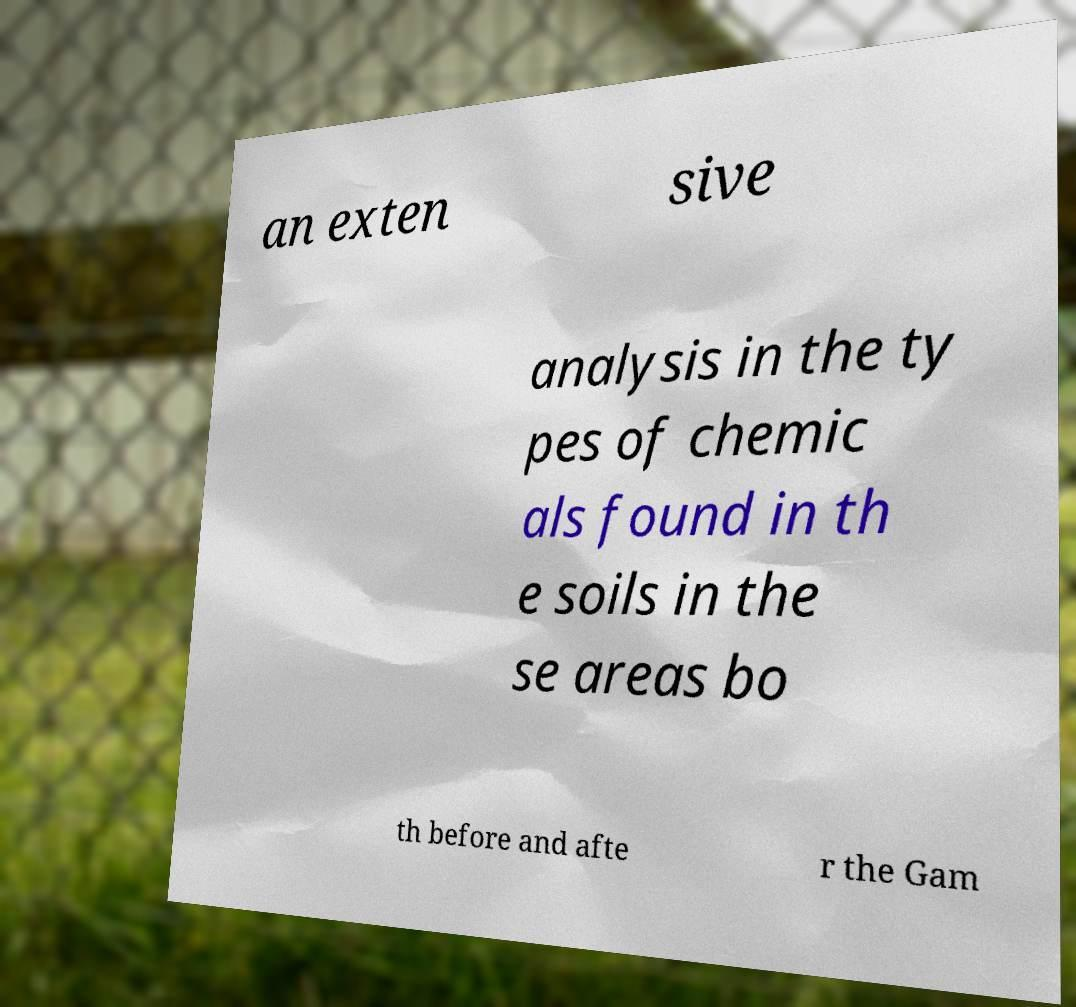Can you read and provide the text displayed in the image?This photo seems to have some interesting text. Can you extract and type it out for me? an exten sive analysis in the ty pes of chemic als found in th e soils in the se areas bo th before and afte r the Gam 